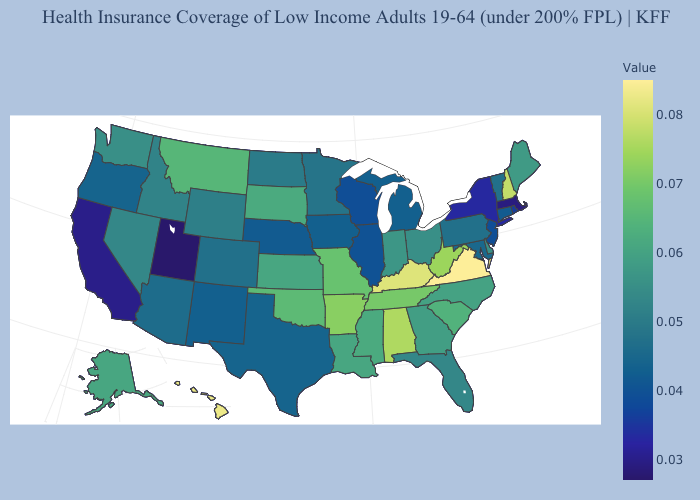Which states have the lowest value in the South?
Concise answer only. Texas. Which states have the lowest value in the South?
Write a very short answer. Texas. 